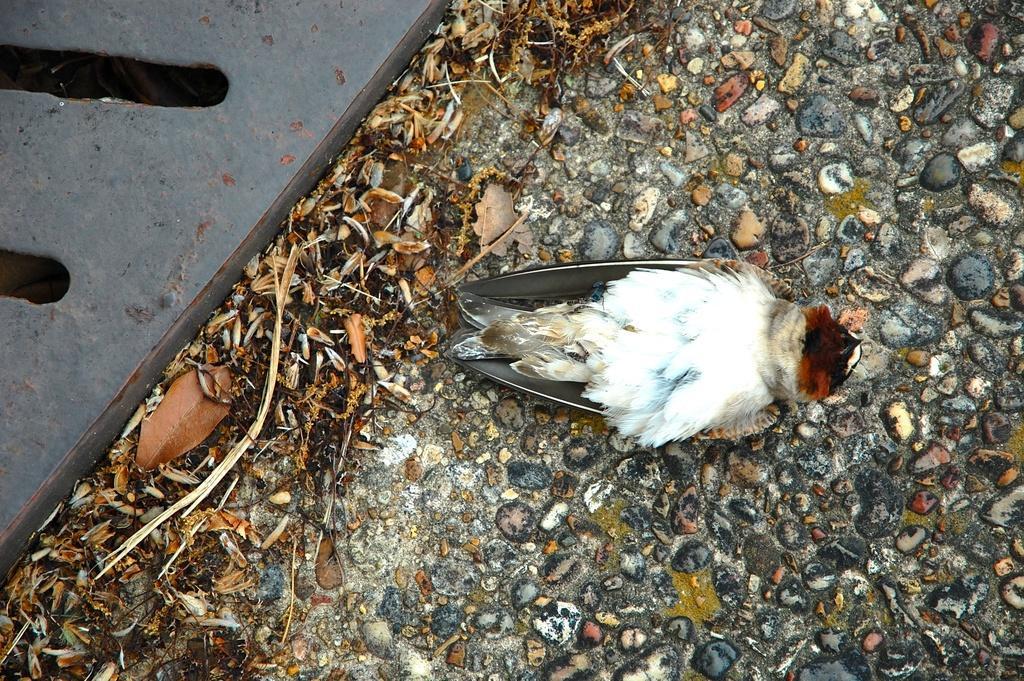Can you describe this image briefly? In this image there is a dead bird on the ground. At the bottom of the image there is a dried grass and a stones on the surface. 